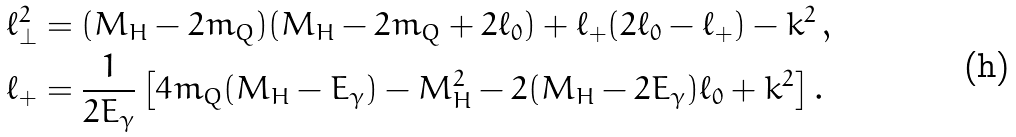Convert formula to latex. <formula><loc_0><loc_0><loc_500><loc_500>\ell _ { \perp } ^ { 2 } & = ( M _ { H } - 2 m _ { Q } ) ( M _ { H } - 2 m _ { Q } + 2 \ell _ { 0 } ) + \ell _ { + } ( 2 \ell _ { 0 } - \ell _ { + } ) - k ^ { 2 } \, , \\ \ell _ { + } & = \frac { 1 } { 2 E _ { \gamma } } \left [ 4 m _ { Q } ( M _ { H } - E _ { \gamma } ) - M _ { H } ^ { 2 } - 2 ( M _ { H } - 2 E _ { \gamma } ) \ell _ { 0 } + k ^ { 2 } \right ] .</formula> 